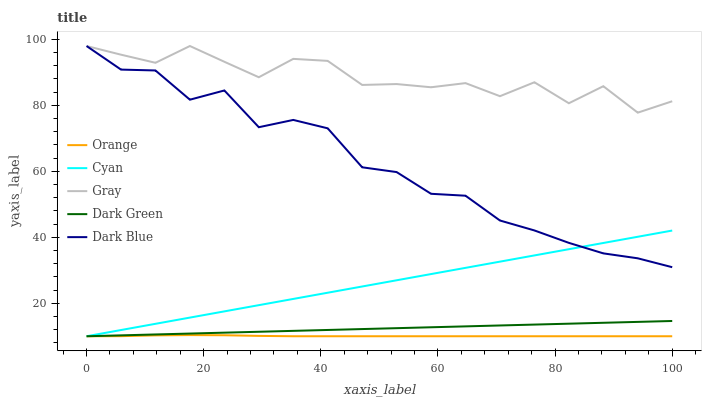Does Orange have the minimum area under the curve?
Answer yes or no. Yes. Does Gray have the maximum area under the curve?
Answer yes or no. Yes. Does Cyan have the minimum area under the curve?
Answer yes or no. No. Does Cyan have the maximum area under the curve?
Answer yes or no. No. Is Dark Green the smoothest?
Answer yes or no. Yes. Is Gray the roughest?
Answer yes or no. Yes. Is Cyan the smoothest?
Answer yes or no. No. Is Cyan the roughest?
Answer yes or no. No. Does Orange have the lowest value?
Answer yes or no. Yes. Does Dark Blue have the lowest value?
Answer yes or no. No. Does Gray have the highest value?
Answer yes or no. Yes. Does Cyan have the highest value?
Answer yes or no. No. Is Orange less than Gray?
Answer yes or no. Yes. Is Dark Blue greater than Dark Green?
Answer yes or no. Yes. Does Dark Blue intersect Cyan?
Answer yes or no. Yes. Is Dark Blue less than Cyan?
Answer yes or no. No. Is Dark Blue greater than Cyan?
Answer yes or no. No. Does Orange intersect Gray?
Answer yes or no. No. 